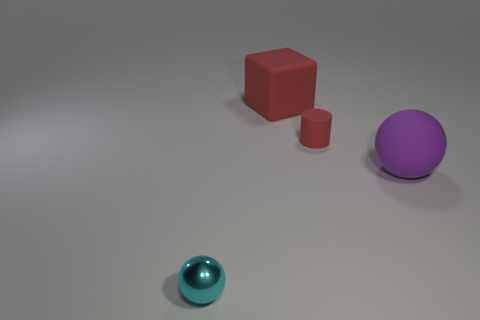What number of objects are there?
Offer a very short reply. 4. There is a matte thing behind the tiny red rubber cylinder; does it have the same size as the sphere in front of the large purple matte ball?
Your answer should be compact. No. There is a big matte object that is the same shape as the cyan metallic thing; what is its color?
Your answer should be very brief. Purple. Does the metal thing have the same shape as the big purple rubber thing?
Offer a very short reply. Yes. What size is the cyan object that is the same shape as the large purple thing?
Your answer should be very brief. Small. What number of large balls have the same material as the tiny cylinder?
Your response must be concise. 1. How many objects are small matte cylinders or large red metal blocks?
Give a very brief answer. 1. There is a large object that is behind the red matte cylinder; is there a cyan metallic thing that is left of it?
Provide a succinct answer. Yes. Are there more spheres that are to the left of the purple rubber object than big matte spheres that are behind the big red thing?
Your answer should be compact. Yes. What number of things are the same color as the rubber cylinder?
Give a very brief answer. 1. 